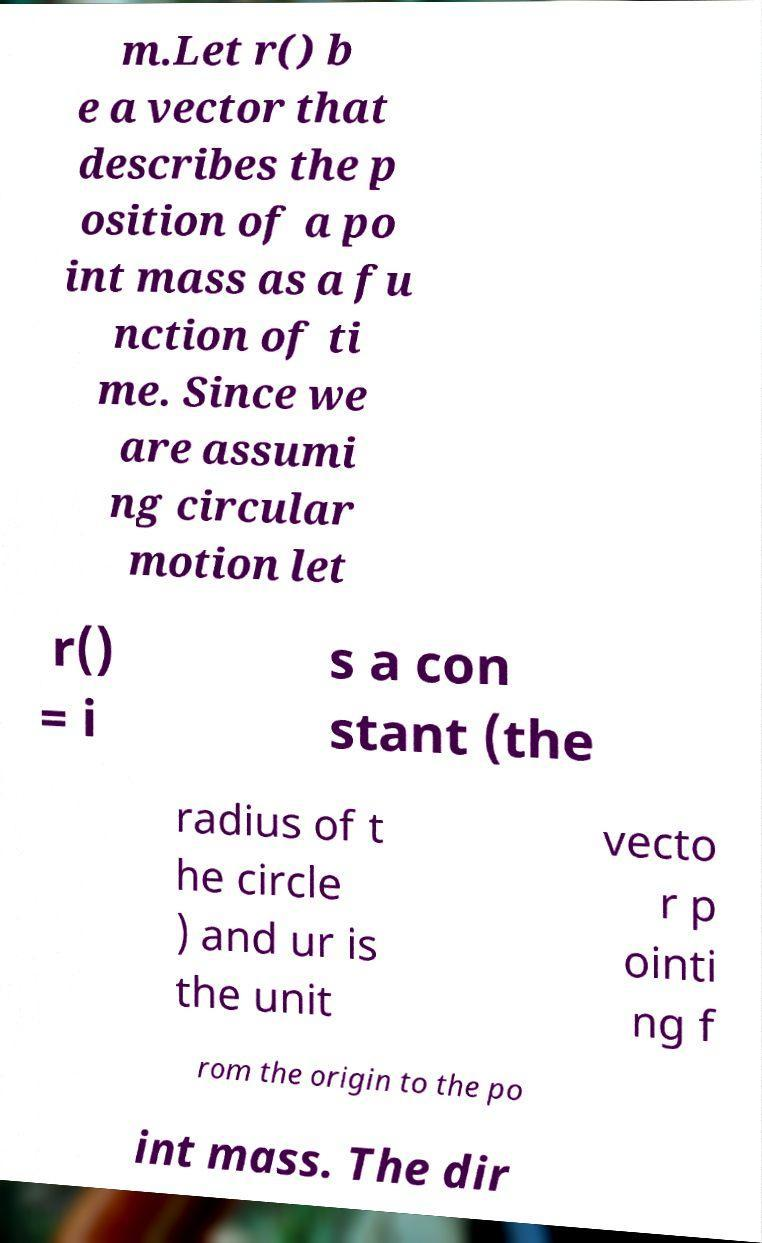I need the written content from this picture converted into text. Can you do that? m.Let r() b e a vector that describes the p osition of a po int mass as a fu nction of ti me. Since we are assumi ng circular motion let r() = i s a con stant (the radius of t he circle ) and ur is the unit vecto r p ointi ng f rom the origin to the po int mass. The dir 